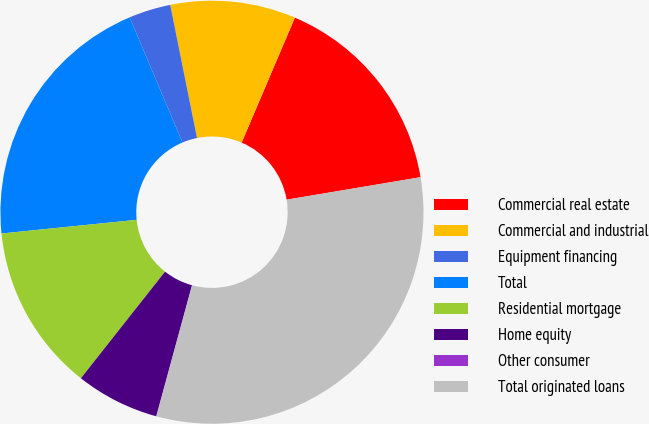Convert chart. <chart><loc_0><loc_0><loc_500><loc_500><pie_chart><fcel>Commercial real estate<fcel>Commercial and industrial<fcel>Equipment financing<fcel>Total<fcel>Residential mortgage<fcel>Home equity<fcel>Other consumer<fcel>Total originated loans<nl><fcel>15.94%<fcel>9.57%<fcel>3.2%<fcel>20.24%<fcel>12.76%<fcel>6.39%<fcel>0.02%<fcel>31.87%<nl></chart> 